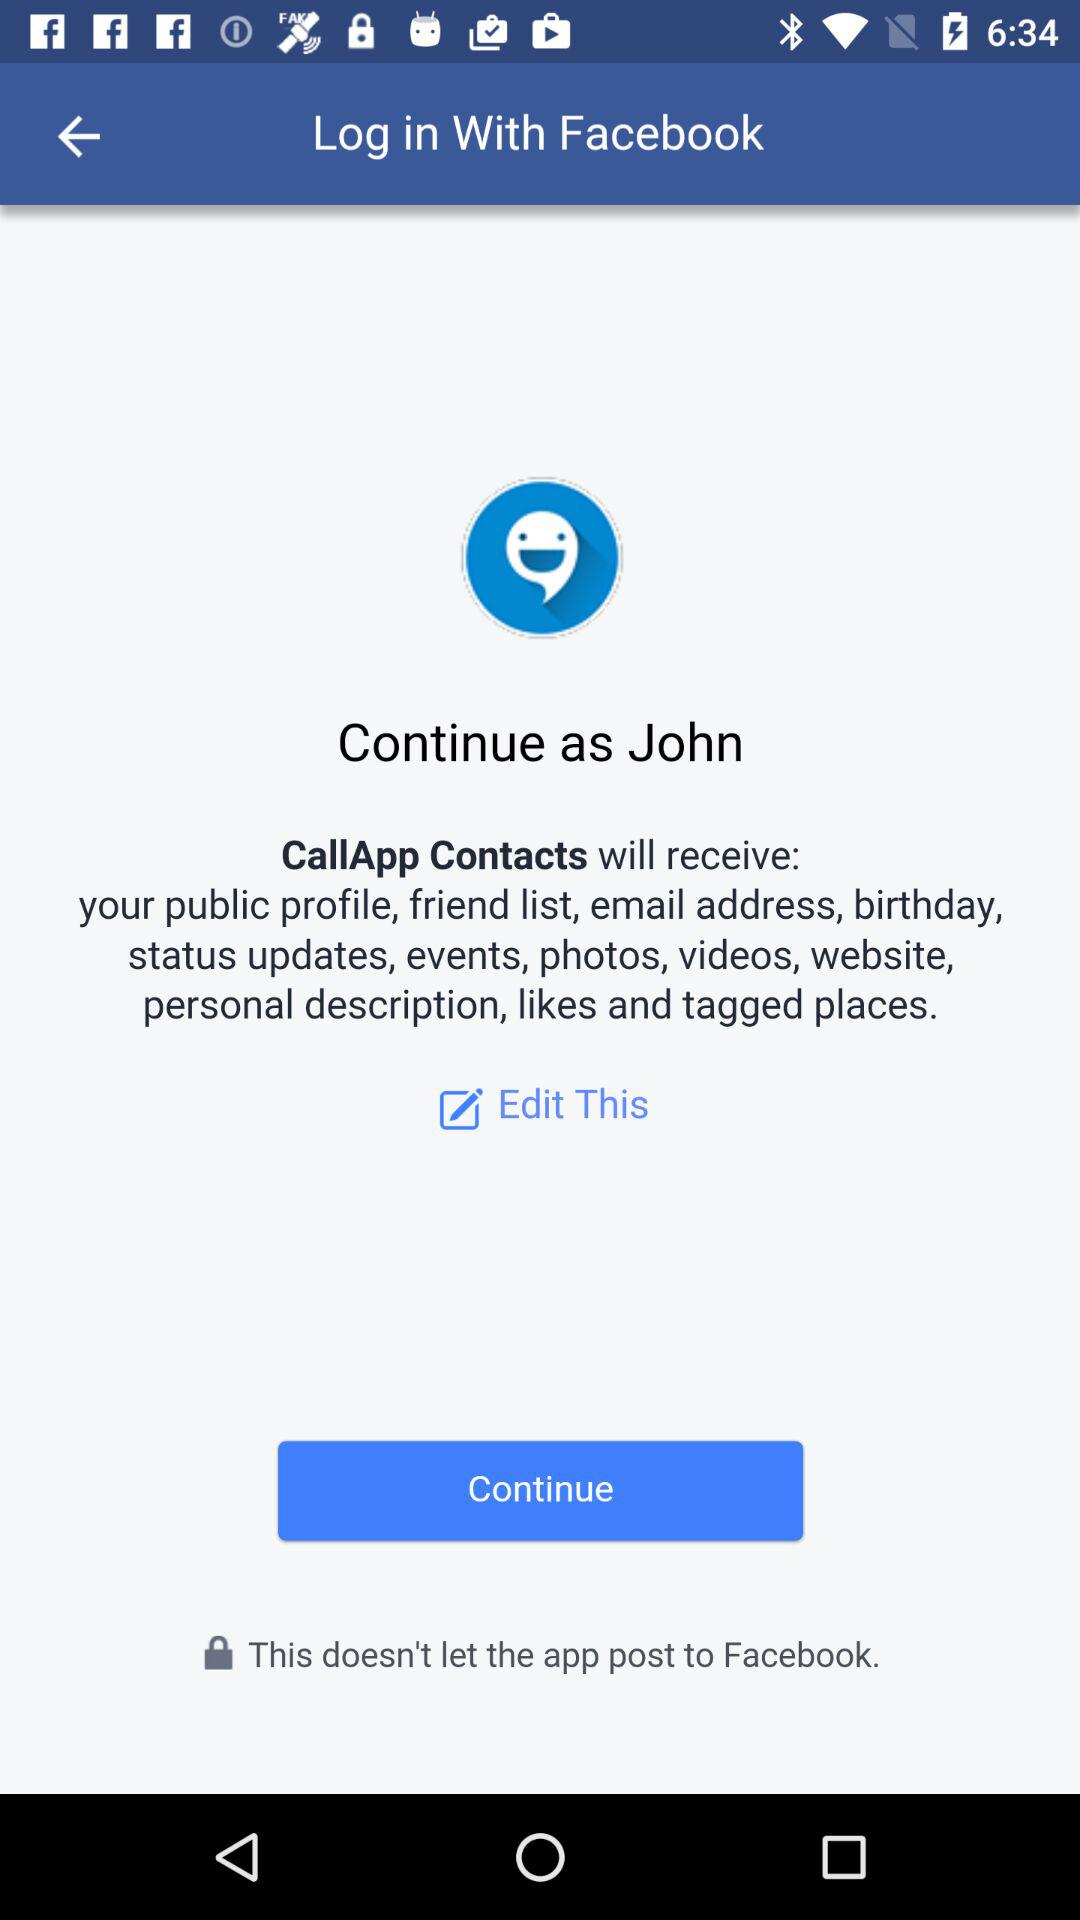Which application will receive my public profile, friend list, email address and birthday? The application is "CallApp Contacts". 